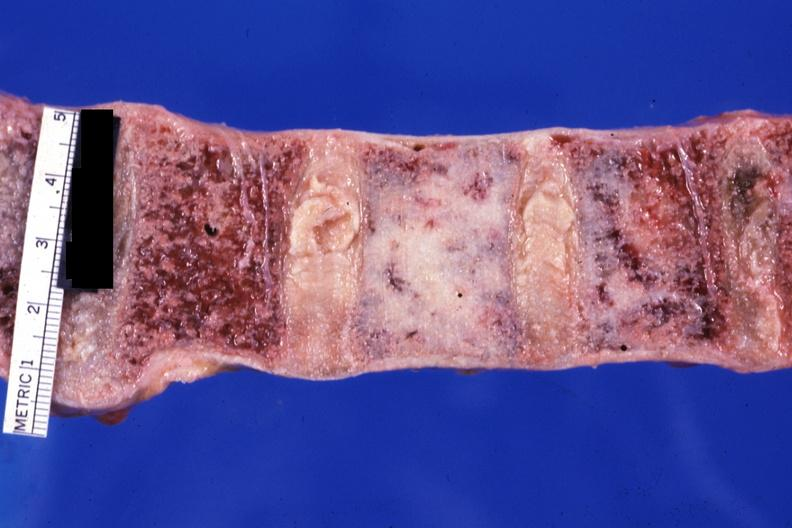what is this of prostatic carcinoma?
Answer the question using a single word or phrase. A case 